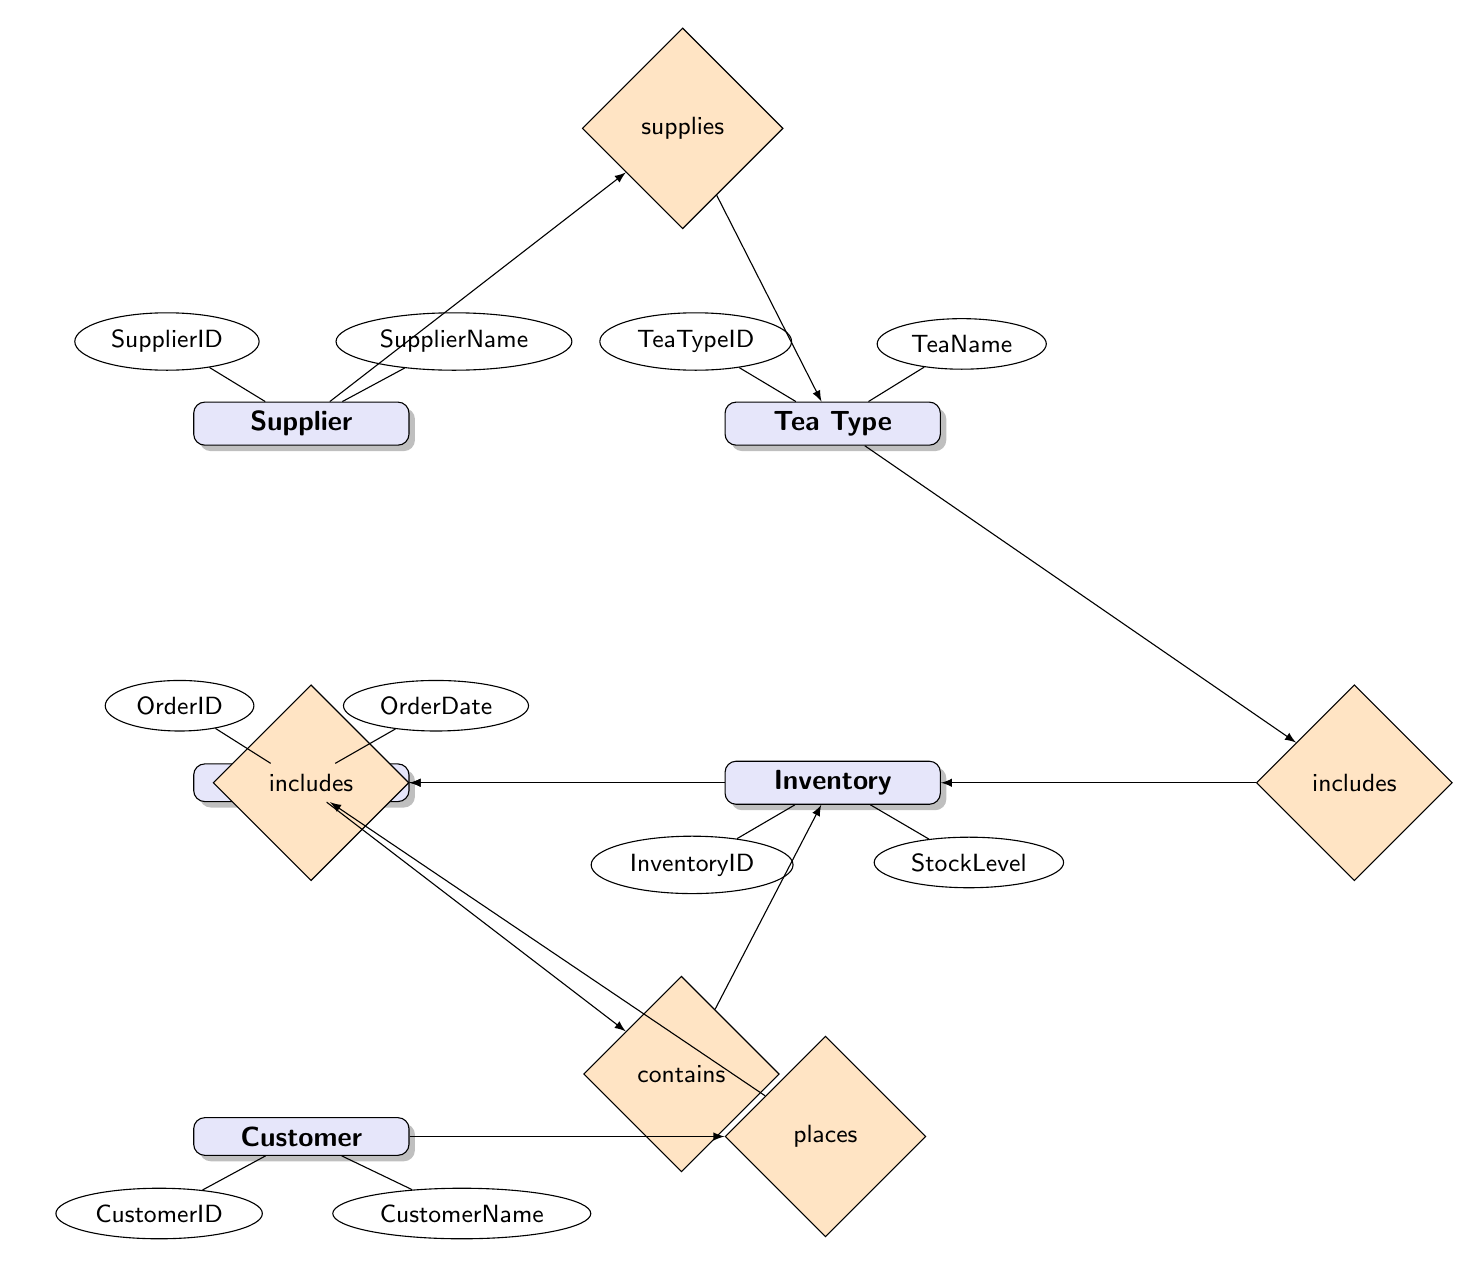What is the total number of entities in the diagram? The diagram shows five distinct entities: Supplier, Tea Type, Inventory, Order, and Customer. Therefore, the count of entities is derived directly from the visual representation of the nodes.
Answer: 5 What relationship connects Supplier to Tea Type? The relationship between Supplier and Tea Type is labeled as "supplies," which indicates a supply relationship. This can be directly observed in the arrow linking these two entities in the diagram.
Answer: supplies Which entity can have multiple instances of Orders? The Customer entity can have multiple instances of Orders since the relationship "places" from Customer to Order is labeled as "one-to-many.” This indicates each customer can place multiple orders, as noted in the flow of relationships in the diagram.
Answer: Customer What is the primary attribute of Inventory that identifies it uniquely? The attribute that uniquely identifies the Inventory entity is "InventoryID," as indicated by the connection from the Inventory entity to its associated attributes in the diagram.
Answer: InventoryID How many total relationships are illustrated in the diagram? The diagram depicts a total of six relationships, which can be counted by identifying the connections between entities and the labeled relationships (supplies, includes, contains, and places).
Answer: 6 What relationship exists between Order and Customer? The relationship between Order and Customer is labeled as "placed by," indicating that orders are created by customers. This is shown in the diagram and can be traced from the respective entities through the connecting relation labeled "placed by."
Answer: placed by 